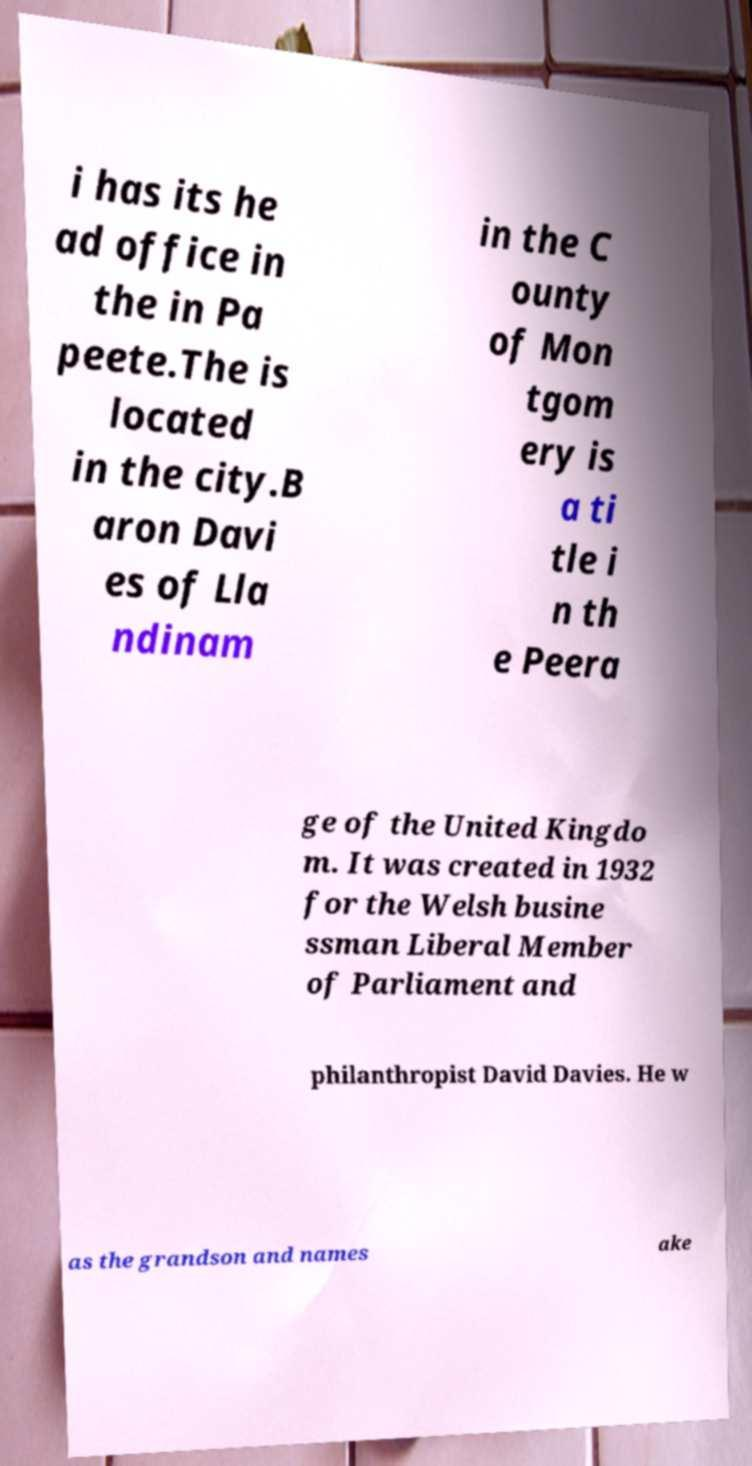Could you extract and type out the text from this image? i has its he ad office in the in Pa peete.The is located in the city.B aron Davi es of Lla ndinam in the C ounty of Mon tgom ery is a ti tle i n th e Peera ge of the United Kingdo m. It was created in 1932 for the Welsh busine ssman Liberal Member of Parliament and philanthropist David Davies. He w as the grandson and names ake 